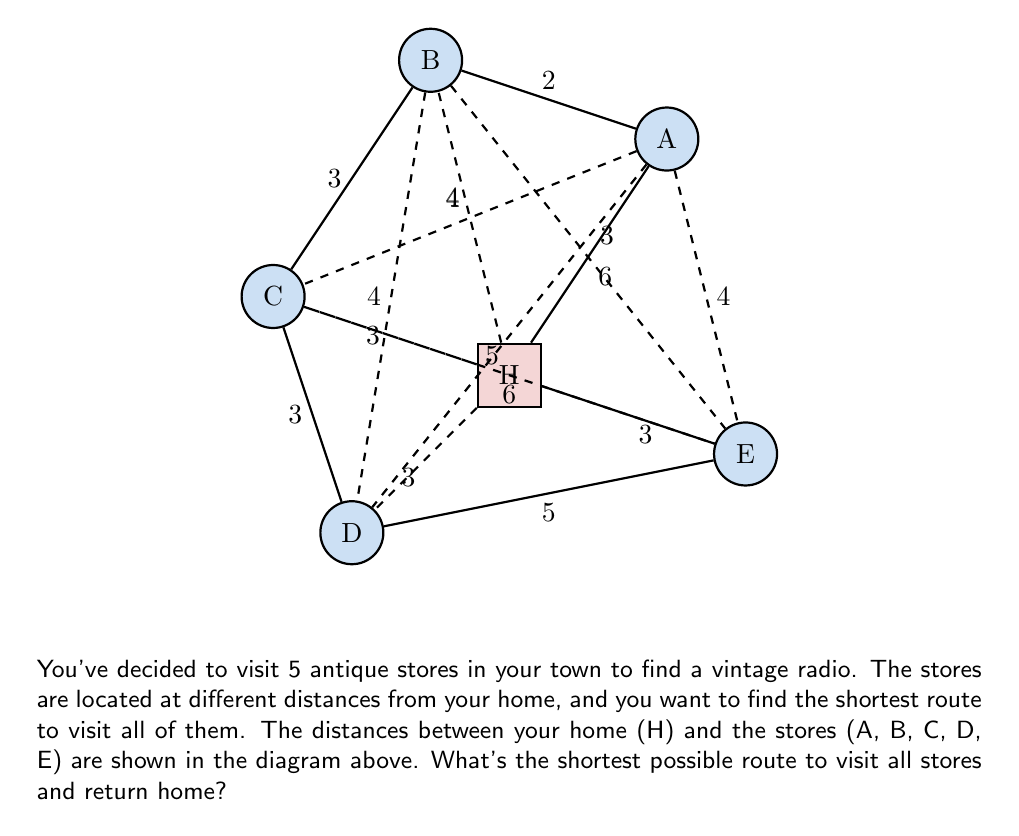Solve this math problem. To solve this problem, we need to use the concept of the Traveling Salesman Problem (TSP). However, given the persona, we'll approach this step-by-step without using complex algorithms.

1) First, let's list all possible routes:
   There are $5! = 120$ possible routes, as we have 5 stores to visit in different orders.

2) However, we can reduce this by considering that we start and end at home (H). So, we only need to permute the 5 stores, giving us $(5-1)! = 24$ routes to consider.

3) Let's calculate the total distance for a few sample routes:

   H-A-B-C-D-E-H: $3 + 2 + 3 + 3 + 5 + 3 = 19$
   H-B-A-C-D-E-H: $4 + 2 + 4 + 3 + 5 + 3 = 21$
   H-C-B-A-D-E-H: $3 + 3 + 2 + 5 + 5 + 3 = 21$

4) After calculating all 24 routes (which would be time-consuming to do by hand), we would find that the shortest route is:

   H-A-B-C-D-E-H with a total distance of 19 units.

5) This route can be described as:
   - Start at home (H)
   - Go to store A (3 units)
   - From A to B (2 units)
   - From B to C (3 units)
   - From C to D (3 units)
   - From D to E (5 units)
   - Return home from E (3 units)

The total distance is: $3 + 2 + 3 + 3 + 5 + 3 = 19$ units.
Answer: H-A-B-C-D-E-H, 19 units 